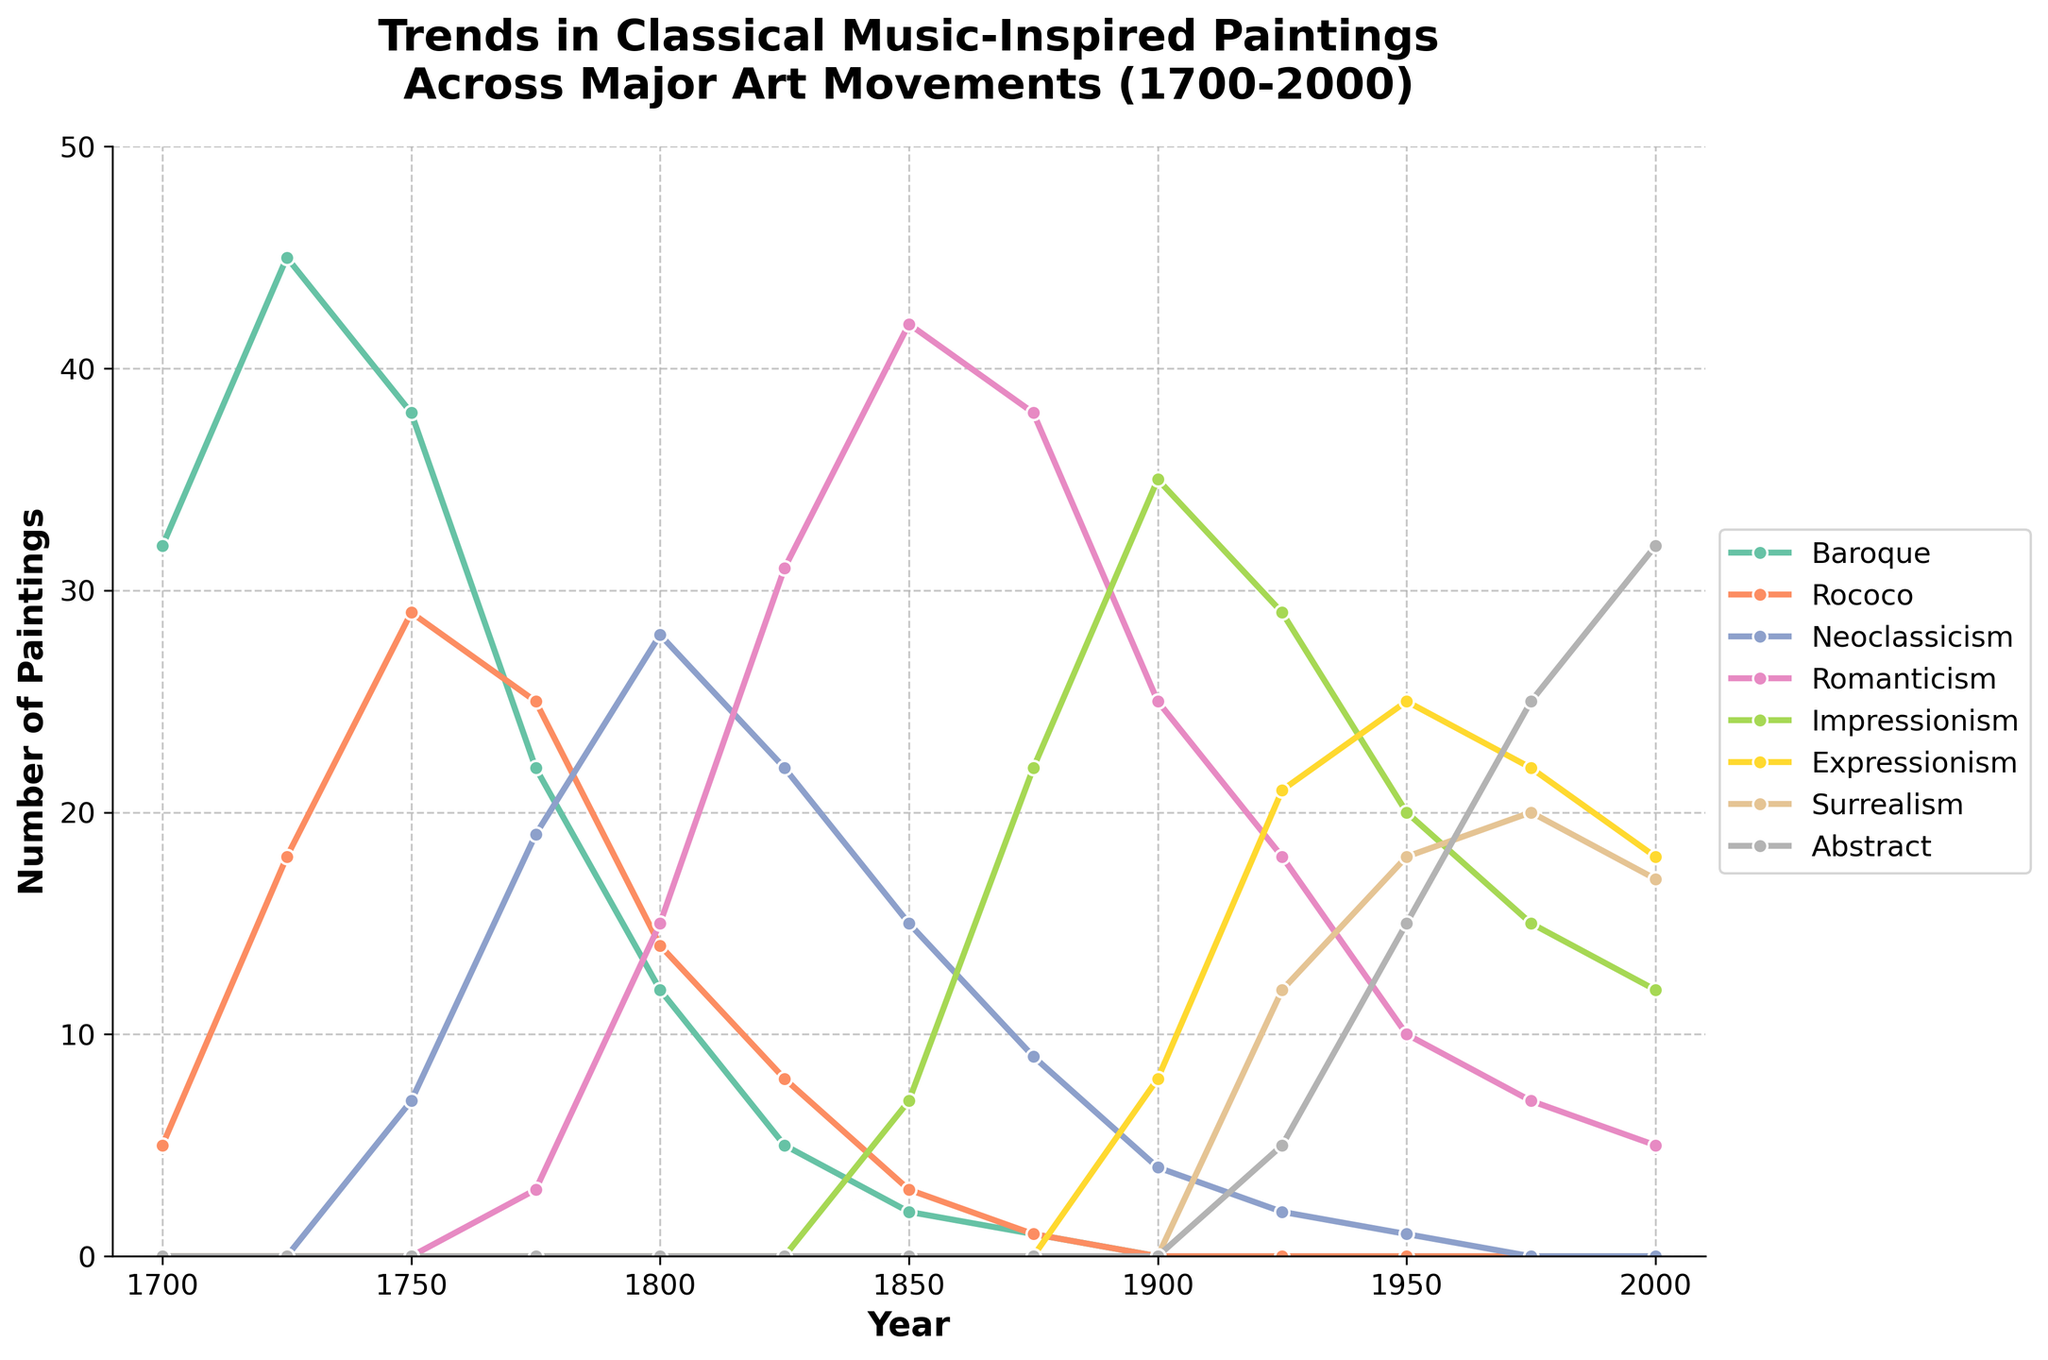When does Rococo see its highest peak in classical music-inspired paintings? Rococo reaches its peak when the number of classical music-inspired paintings in that style is at its highest. Observing the Rococo line, the highest value is 29, which occurs in 1750.
Answer: 1750 How does the number of classical music-inspired paintings in the Baroque style in 1750 compare to those in Romanticism in 1850? To compare, look at the values for Baroque in 1750 and Romanticism in 1850. Baroque in 1750 has 38 paintings, while Romanticism in 1850 has 42. Thus, Romanticism in 1850 has more paintings (42) compared to Baroque in 1750 (38).
Answer: Romanticism is greater What is the range of the number of classical music-inspired paintings in the Abstract style? The range is defined as the difference between the maximum and minimum values. For Abstract, the minimum value is 0 (until 1925) and the maximum value is 32 (in 2000). So, the range is 32 - 0 = 32.
Answer: 32 Which art movement had the first instance of classical music-inspired paintings? The first instance can be identified by observing the first year any movement has a non-zero value. Baroque in 1700 shows 32 paintings, making it the first.
Answer: Baroque What is the sum of classical music-inspired paintings in Impressionism and Expressionism in 1950? To find the sum, add the values for Impressionism and Expressionism in 1950. Impressionism has 20 paintings and Expressionism has 25 paintings in 1950. So, 20 + 25 = 45 paintings.
Answer: 45 In what year did Neoclassicism start to emerge, and with how many paintings? Neoclassicism starts to show classical music-inspired paintings when its value first becomes non-zero. This occurs in the year 1750 with 7 paintings.
Answer: 1750, 7 How many classical music-inspired paintings were produced in the Romanticism style at its peak? To find the peak, look for the maximum value in the Romanticism line. The highest number is 42, which occurs in 1850.
Answer: 42 Compare the number of classical music-inspired paintings in Surrealism in 1925 with those in Abstract in 1975. Which year had a greater number? In 1925, Surrealism has 12 paintings. In 1975, Abstract has 25 paintings. Comparing these values, Abstract in 1975 has more paintings (25) compared to Surrealism in 1925 (12).
Answer: Abstract in 1975 How many years did it take for the Rococo movement to go from 5 to 29 paintings? Rococo had 5 paintings in 1700 and reached 29 paintings in 1750. Thus, the number of years taken is 1750 - 1700 = 50 years.
Answer: 50 years What was the trend of classical music-inspired paintings in Surrealism between 1950 and 2000? To determine the trend, observe the values for Surrealism between 1950 and 2000. In 1950 there are 18 paintings, in 1975 there are 20, and in 2000 there are 17. This indicates a slight increase initially followed by a small decrease, showing an overall fairly stable or slightly fluctuating trend.
Answer: Stable/Fluctuating 